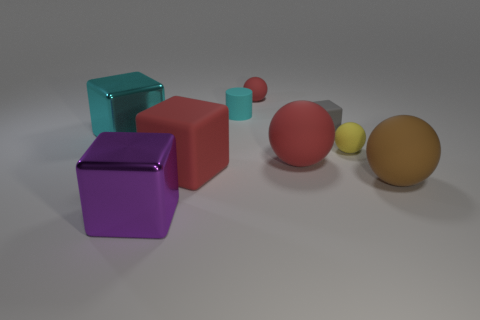Add 1 big red cubes. How many objects exist? 10 Subtract all cubes. How many objects are left? 5 Add 2 big brown things. How many big brown things are left? 3 Add 5 small brown shiny blocks. How many small brown shiny blocks exist? 5 Subtract 0 brown cylinders. How many objects are left? 9 Subtract all large gray metallic spheres. Subtract all big cyan shiny objects. How many objects are left? 8 